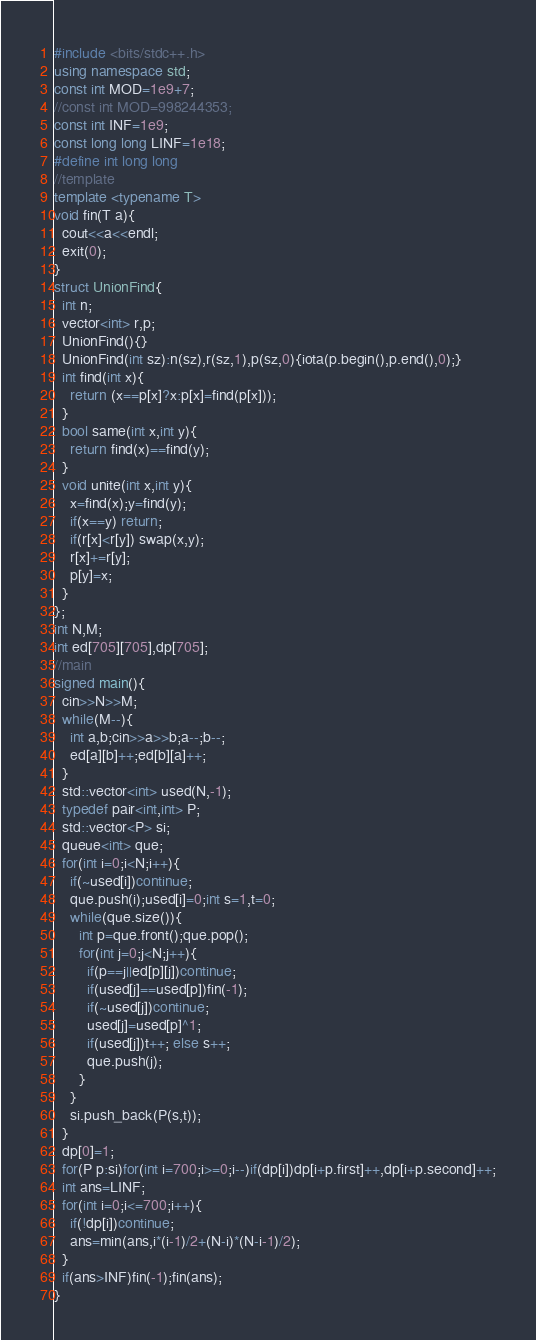Convert code to text. <code><loc_0><loc_0><loc_500><loc_500><_C++_>#include <bits/stdc++.h>
using namespace std;
const int MOD=1e9+7;
//const int MOD=998244353;
const int INF=1e9;
const long long LINF=1e18;
#define int long long
//template
template <typename T>
void fin(T a){
  cout<<a<<endl;
  exit(0);
}
struct UnionFind{
  int n;
  vector<int> r,p;
  UnionFind(){}
  UnionFind(int sz):n(sz),r(sz,1),p(sz,0){iota(p.begin(),p.end(),0);}
  int find(int x){
    return (x==p[x]?x:p[x]=find(p[x]));
  }
  bool same(int x,int y){
    return find(x)==find(y);
  }
  void unite(int x,int y){
    x=find(x);y=find(y);
    if(x==y) return;
    if(r[x]<r[y]) swap(x,y);
    r[x]+=r[y];
    p[y]=x;
  }
};
int N,M;
int ed[705][705],dp[705];
//main
signed main(){
  cin>>N>>M;
  while(M--){
    int a,b;cin>>a>>b;a--;b--;
    ed[a][b]++;ed[b][a]++;
  }
  std::vector<int> used(N,-1);
  typedef pair<int,int> P;
  std::vector<P> si;
  queue<int> que;
  for(int i=0;i<N;i++){
    if(~used[i])continue;
    que.push(i);used[i]=0;int s=1,t=0;
    while(que.size()){
      int p=que.front();que.pop();
      for(int j=0;j<N;j++){
        if(p==j||ed[p][j])continue;
        if(used[j]==used[p])fin(-1);
        if(~used[j])continue;
        used[j]=used[p]^1;
        if(used[j])t++; else s++;
        que.push(j);
      }
    }
    si.push_back(P(s,t));
  }
  dp[0]=1;
  for(P p:si)for(int i=700;i>=0;i--)if(dp[i])dp[i+p.first]++,dp[i+p.second]++;
  int ans=LINF;
  for(int i=0;i<=700;i++){
    if(!dp[i])continue;
    ans=min(ans,i*(i-1)/2+(N-i)*(N-i-1)/2);
  }
  if(ans>INF)fin(-1);fin(ans);
}
</code> 